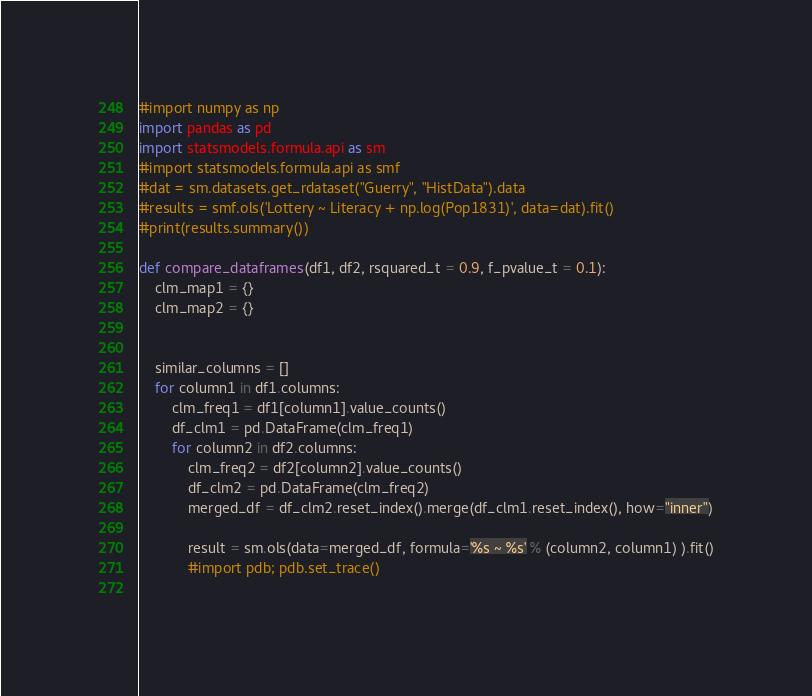<code> <loc_0><loc_0><loc_500><loc_500><_Python_>#import numpy as np
import pandas as pd
import statsmodels.formula.api as sm
#import statsmodels.formula.api as smf
#dat = sm.datasets.get_rdataset("Guerry", "HistData").data
#results = smf.ols('Lottery ~ Literacy + np.log(Pop1831)', data=dat).fit()
#print(results.summary())

def compare_dataframes(df1, df2, rsquared_t = 0.9, f_pvalue_t = 0.1):
	clm_map1 = {}
	clm_map2 = {}


	similar_columns = []
	for column1 in df1.columns:
		clm_freq1 = df1[column1].value_counts()
		df_clm1 = pd.DataFrame(clm_freq1)
		for column2 in df2.columns:
			clm_freq2 = df2[column2].value_counts()
			df_clm2 = pd.DataFrame(clm_freq2)
			merged_df = df_clm2.reset_index().merge(df_clm1.reset_index(), how="inner")
			
			result = sm.ols(data=merged_df, formula='%s ~ %s' % (column2, column1) ).fit()
			#import pdb; pdb.set_trace()
			</code> 